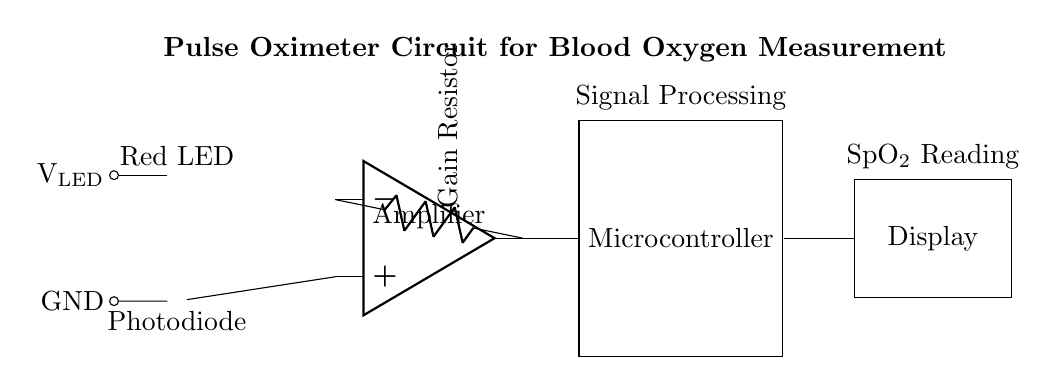What components are used in this circuit? The components visible in the circuit are a red LED, a photodiode, an operational amplifier (op amp), a microcontroller, and a display.
Answer: Red LED, photodiode, op amp, microcontroller, display What is the function of the photodiode? The photodiode is used to detect the light emitted by the red LED and convert it into an electrical signal that is proportional to the light intensity.
Answer: Light detection What is the purpose of the amplifier in this circuit? The operational amplifier amplifies the weak signal from the photodiode to make it strong enough for processing by the microcontroller.
Answer: Signal amplification What will the display show? The display shows the SpO2 reading, which indicates the blood oxygen saturation level measured by the circuit.
Answer: SpO2 reading How does the circuit measure blood oxygen levels? The circuit measures blood oxygen levels by sending light from the LED through the blood, detecting the light absorption with the photodiode, and processing the resulting signal to determine oxygen saturation.
Answer: Signal processing through light absorption What is the role of the microcontroller in the circuit? The microcontroller processes the amplified signal from the operational amplifier and calculates the blood oxygen saturation levels to be displayed.
Answer: Signal processing 